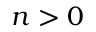<formula> <loc_0><loc_0><loc_500><loc_500>n > 0</formula> 